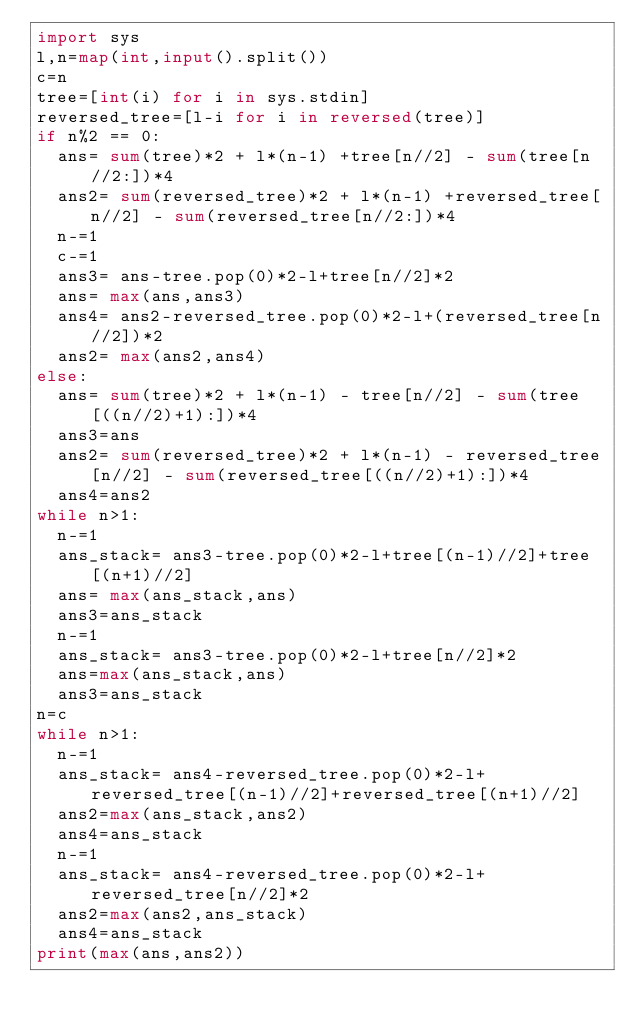<code> <loc_0><loc_0><loc_500><loc_500><_Python_>import sys
l,n=map(int,input().split())
c=n
tree=[int(i) for i in sys.stdin]
reversed_tree=[l-i for i in reversed(tree)]
if n%2 == 0:
  ans= sum(tree)*2 + l*(n-1) +tree[n//2] - sum(tree[n//2:])*4
  ans2= sum(reversed_tree)*2 + l*(n-1) +reversed_tree[n//2] - sum(reversed_tree[n//2:])*4
  n-=1
  c-=1
  ans3= ans-tree.pop(0)*2-l+tree[n//2]*2
  ans= max(ans,ans3)
  ans4= ans2-reversed_tree.pop(0)*2-l+(reversed_tree[n//2])*2
  ans2= max(ans2,ans4)
else:
  ans= sum(tree)*2 + l*(n-1) - tree[n//2] - sum(tree[((n//2)+1):])*4
  ans3=ans
  ans2= sum(reversed_tree)*2 + l*(n-1) - reversed_tree[n//2] - sum(reversed_tree[((n//2)+1):])*4
  ans4=ans2
while n>1:
  n-=1
  ans_stack= ans3-tree.pop(0)*2-l+tree[(n-1)//2]+tree[(n+1)//2]
  ans= max(ans_stack,ans)
  ans3=ans_stack
  n-=1
  ans_stack= ans3-tree.pop(0)*2-l+tree[n//2]*2
  ans=max(ans_stack,ans)
  ans3=ans_stack
n=c
while n>1:
  n-=1
  ans_stack= ans4-reversed_tree.pop(0)*2-l+reversed_tree[(n-1)//2]+reversed_tree[(n+1)//2]
  ans2=max(ans_stack,ans2)
  ans4=ans_stack
  n-=1
  ans_stack= ans4-reversed_tree.pop(0)*2-l+reversed_tree[n//2]*2
  ans2=max(ans2,ans_stack)
  ans4=ans_stack
print(max(ans,ans2))
</code> 